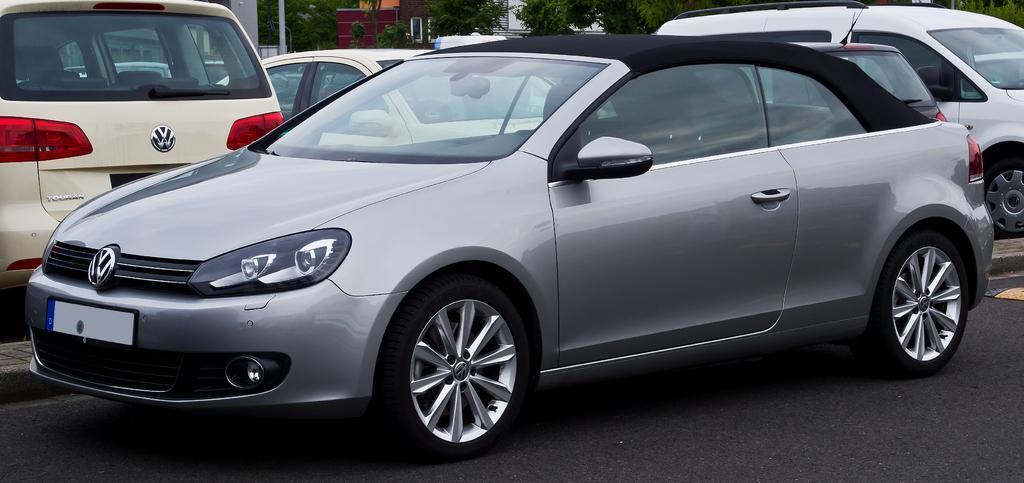Can you describe this image briefly? In this image I can see few vehicles and in the background I can see few buildings and number of trees. 